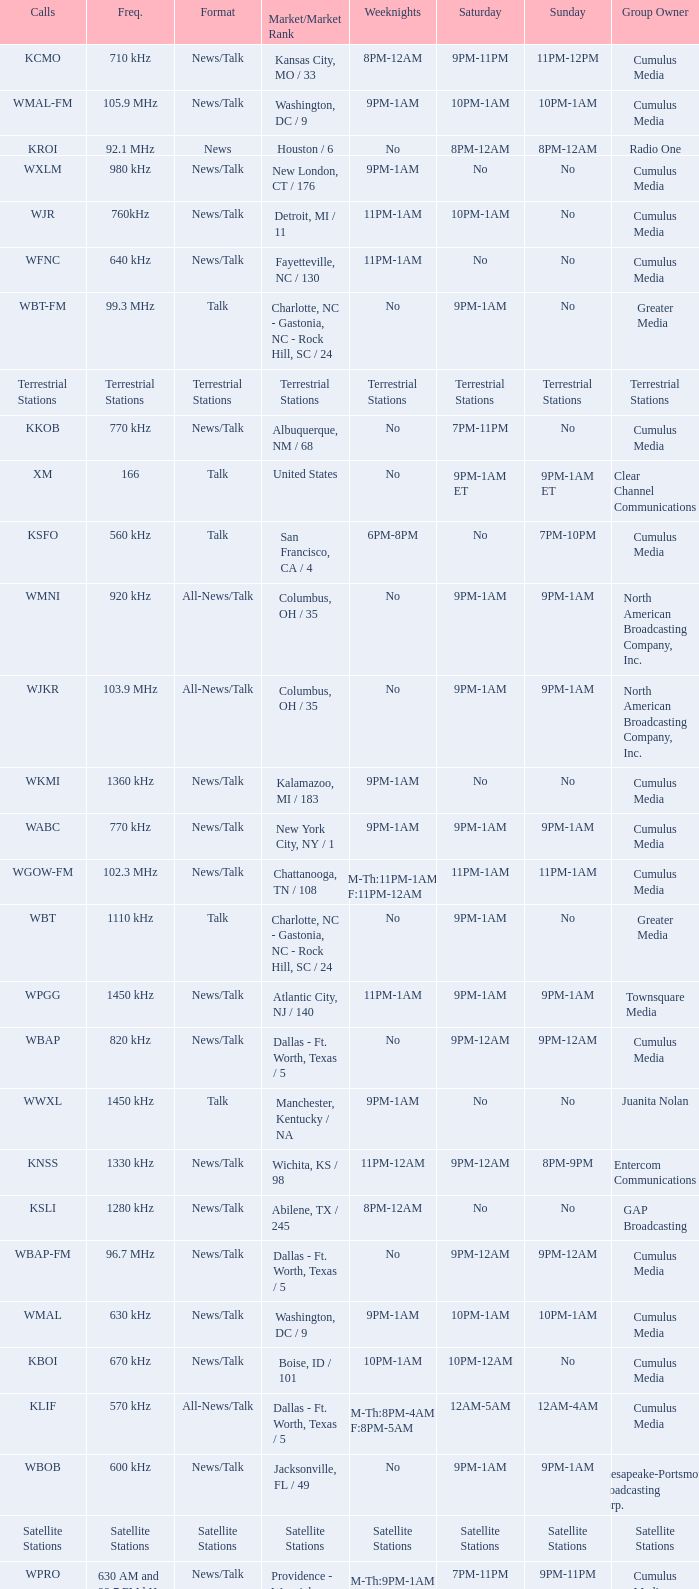What is the market for the 11pm-1am Saturday game? Chattanooga, TN / 108. 